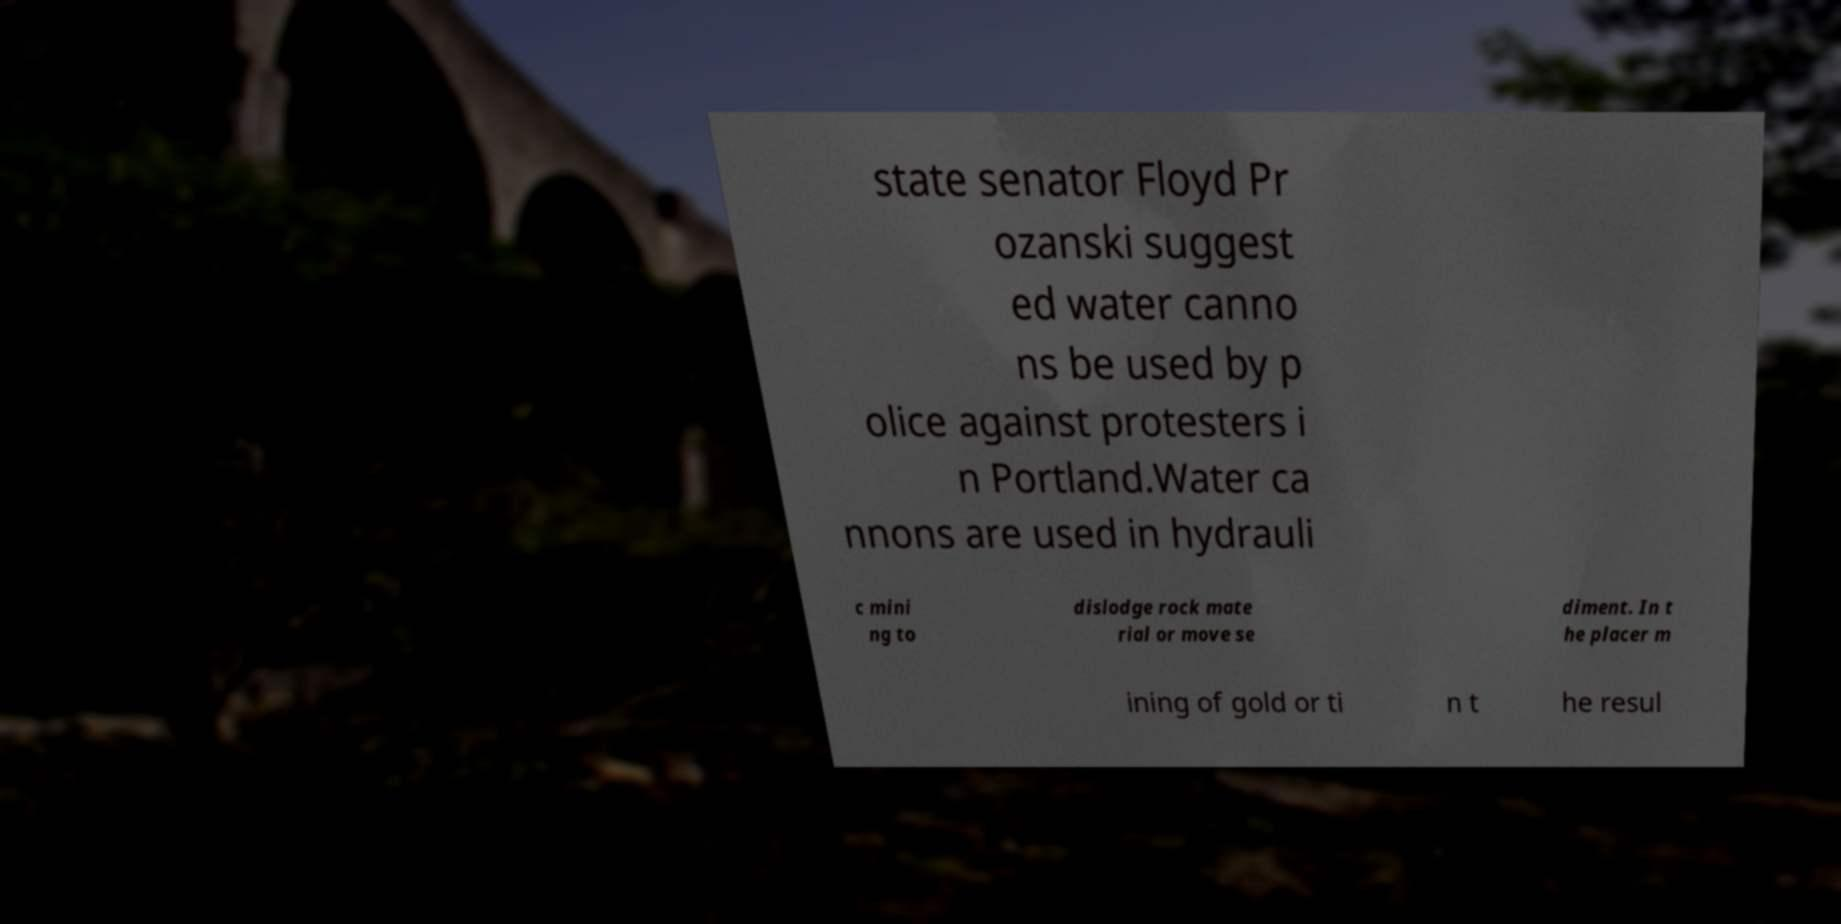Can you read and provide the text displayed in the image?This photo seems to have some interesting text. Can you extract and type it out for me? state senator Floyd Pr ozanski suggest ed water canno ns be used by p olice against protesters i n Portland.Water ca nnons are used in hydrauli c mini ng to dislodge rock mate rial or move se diment. In t he placer m ining of gold or ti n t he resul 